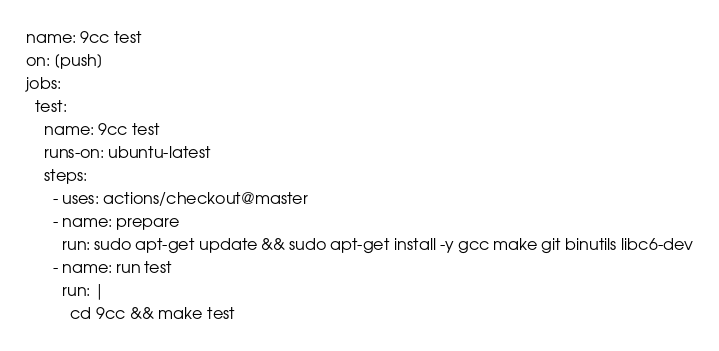<code> <loc_0><loc_0><loc_500><loc_500><_YAML_>name: 9cc test
on: [push]
jobs:
  test:
    name: 9cc test
    runs-on: ubuntu-latest
    steps:
      - uses: actions/checkout@master
      - name: prepare
        run: sudo apt-get update && sudo apt-get install -y gcc make git binutils libc6-dev
      - name: run test
        run: |
          cd 9cc && make test
</code> 